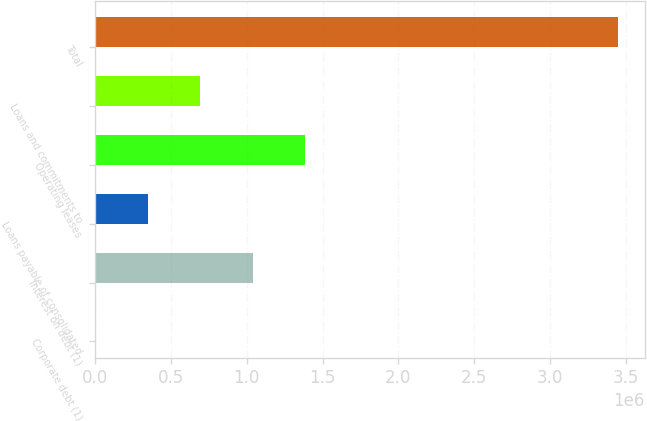Convert chart. <chart><loc_0><loc_0><loc_500><loc_500><bar_chart><fcel>Corporate debt (1)<fcel>Interest on debt (1)<fcel>Loans payable of consolidated<fcel>Operating leases<fcel>Loans and commitments to<fcel>Total<nl><fcel>3530<fcel>1.03787e+06<fcel>348310<fcel>1.38265e+06<fcel>693091<fcel>3.45134e+06<nl></chart> 